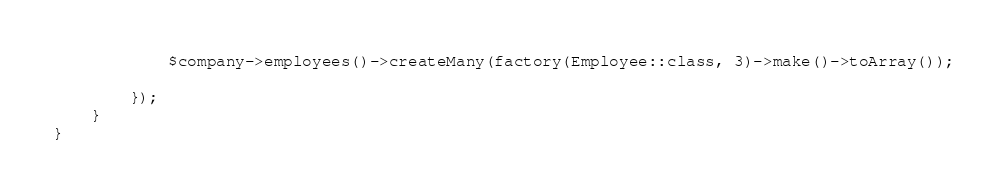<code> <loc_0><loc_0><loc_500><loc_500><_PHP_>            $company->employees()->createMany(factory(Employee::class, 3)->make()->toArray());

        });
    }
}
</code> 